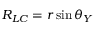<formula> <loc_0><loc_0><loc_500><loc_500>R _ { L C } = r \sin \theta _ { Y }</formula> 